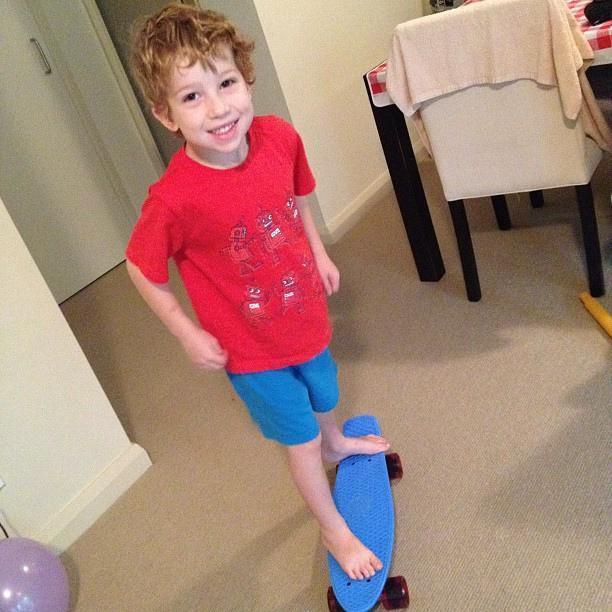How many cars are visible?
Give a very brief answer. 0. 